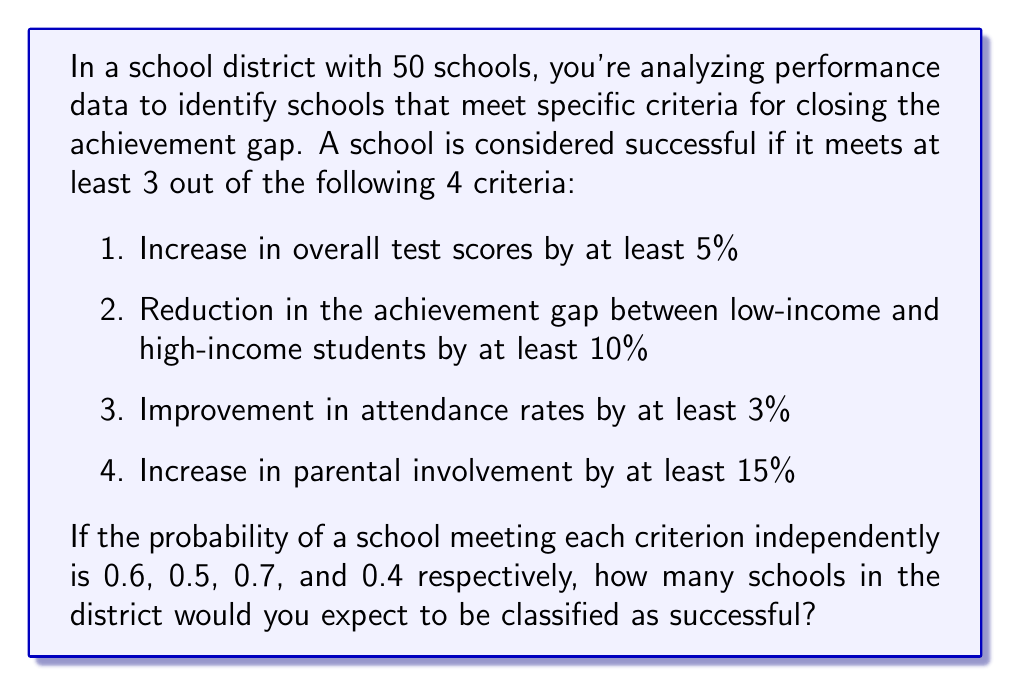Help me with this question. To solve this problem, we need to use the concept of binomial probability and the complement rule. Let's break it down step-by-step:

1) First, we need to calculate the probability of a school being successful. A school is successful if it meets at least 3 out of 4 criteria.

2) The probability of meeting exactly 4 criteria is:
   $$P(4) = 0.6 \times 0.5 \times 0.7 \times 0.4 = 0.084$$

3) The probability of meeting exactly 3 criteria can be calculated as:
   $$P(3) = \binom{4}{3}(0.6 \times 0.5 \times 0.7 \times 0.6) + \binom{4}{3}(0.6 \times 0.5 \times 0.3 \times 0.4) + \binom{4}{3}(0.6 \times 0.5 \times 0.7 \times 0.4) + \binom{4}{3}(0.4 \times 0.5 \times 0.7 \times 0.4)$$
   $$P(3) = 4(0.126 + 0.036 + 0.084 + 0.056) = 1.208$$

4) The total probability of a school being successful is:
   $$P(\text{success}) = P(3) + P(4) = 1.208 + 0.084 = 0.292$$

5) In a binomial distribution, the expected number of successes is given by $np$, where $n$ is the number of trials and $p$ is the probability of success.

6) In this case, $n = 50$ (number of schools) and $p = 0.292$ (probability of a school being successful).

7) Therefore, the expected number of successful schools is:
   $$E(\text{successful schools}) = 50 \times 0.292 = 14.6$$
Answer: The expected number of schools classified as successful is 14.6 or approximately 15 schools. 